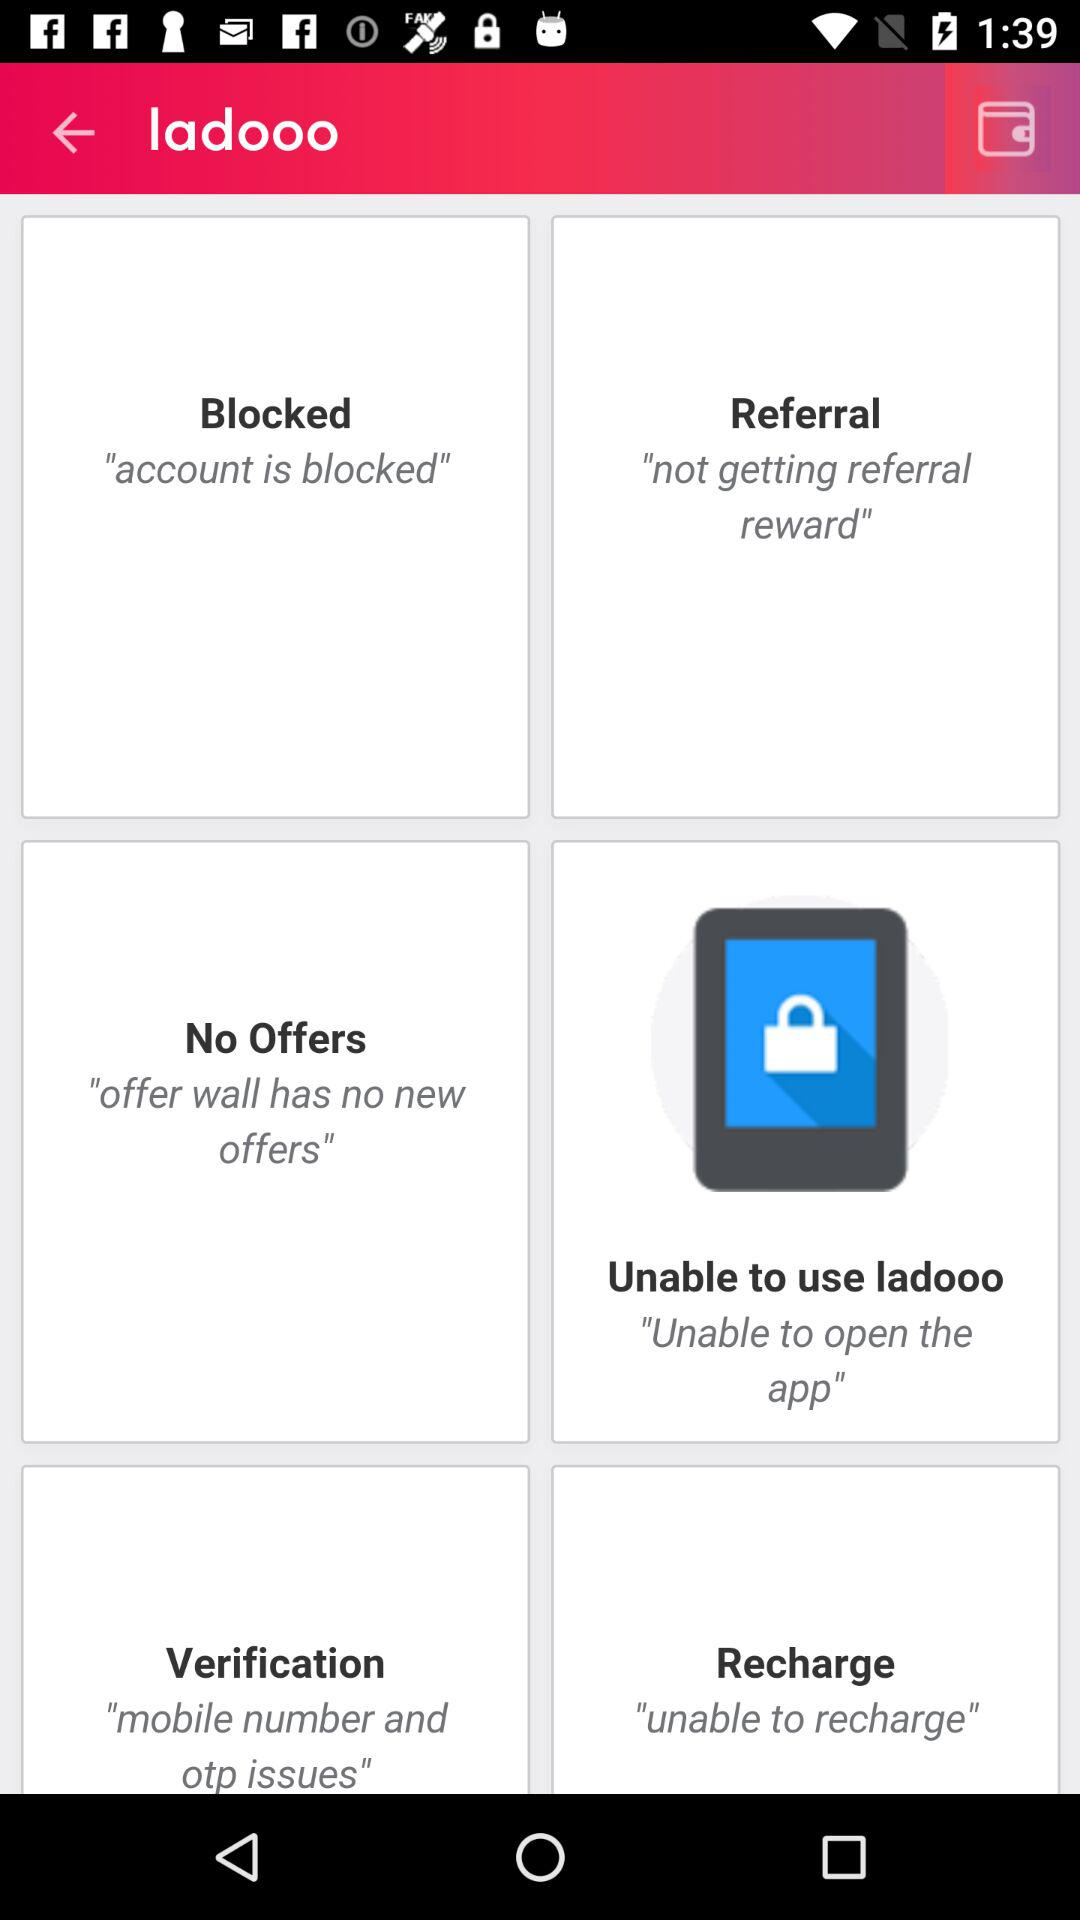What is the name of the application? The name of the application is "ladooo". 